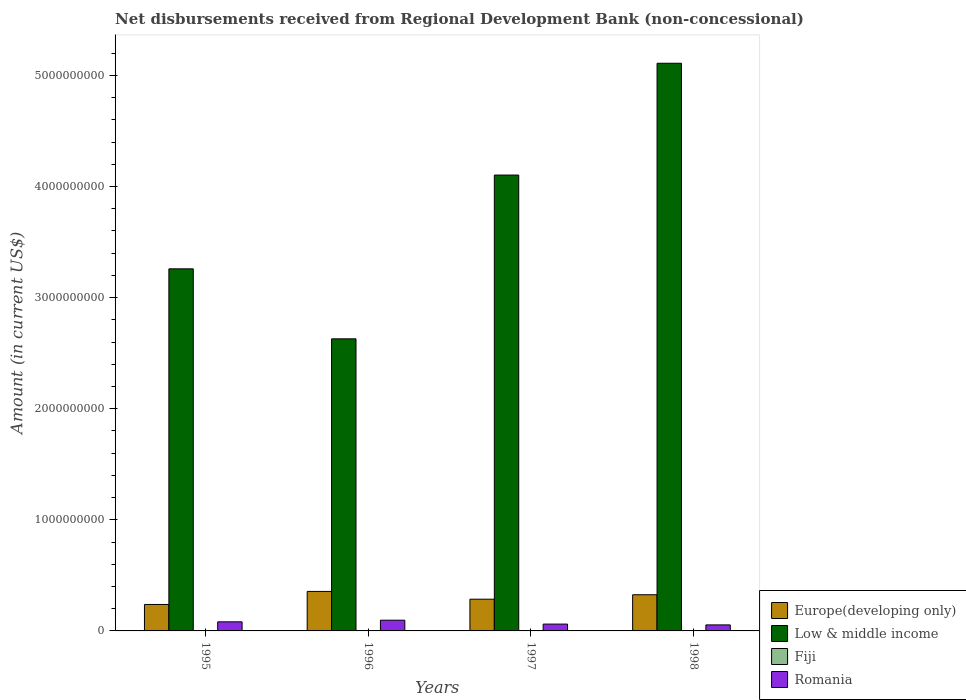How many different coloured bars are there?
Make the answer very short. 4. Are the number of bars per tick equal to the number of legend labels?
Ensure brevity in your answer.  No. Are the number of bars on each tick of the X-axis equal?
Your response must be concise. No. How many bars are there on the 4th tick from the left?
Your answer should be compact. 3. In how many cases, is the number of bars for a given year not equal to the number of legend labels?
Give a very brief answer. 3. What is the amount of disbursements received from Regional Development Bank in Fiji in 1995?
Provide a short and direct response. 8.55e+05. Across all years, what is the maximum amount of disbursements received from Regional Development Bank in Fiji?
Keep it short and to the point. 8.55e+05. Across all years, what is the minimum amount of disbursements received from Regional Development Bank in Fiji?
Your answer should be compact. 0. In which year was the amount of disbursements received from Regional Development Bank in Romania maximum?
Offer a terse response. 1996. What is the total amount of disbursements received from Regional Development Bank in Fiji in the graph?
Provide a succinct answer. 8.55e+05. What is the difference between the amount of disbursements received from Regional Development Bank in Low & middle income in 1995 and that in 1997?
Keep it short and to the point. -8.44e+08. What is the difference between the amount of disbursements received from Regional Development Bank in Fiji in 1996 and the amount of disbursements received from Regional Development Bank in Low & middle income in 1995?
Offer a very short reply. -3.26e+09. What is the average amount of disbursements received from Regional Development Bank in Low & middle income per year?
Your answer should be compact. 3.78e+09. In the year 1995, what is the difference between the amount of disbursements received from Regional Development Bank in Romania and amount of disbursements received from Regional Development Bank in Fiji?
Your answer should be very brief. 8.10e+07. What is the ratio of the amount of disbursements received from Regional Development Bank in Low & middle income in 1995 to that in 1997?
Your response must be concise. 0.79. Is the amount of disbursements received from Regional Development Bank in Romania in 1996 less than that in 1998?
Your response must be concise. No. What is the difference between the highest and the second highest amount of disbursements received from Regional Development Bank in Europe(developing only)?
Your response must be concise. 3.00e+07. What is the difference between the highest and the lowest amount of disbursements received from Regional Development Bank in Europe(developing only)?
Ensure brevity in your answer.  1.17e+08. Is the sum of the amount of disbursements received from Regional Development Bank in Low & middle income in 1997 and 1998 greater than the maximum amount of disbursements received from Regional Development Bank in Europe(developing only) across all years?
Offer a terse response. Yes. Is it the case that in every year, the sum of the amount of disbursements received from Regional Development Bank in Europe(developing only) and amount of disbursements received from Regional Development Bank in Low & middle income is greater than the sum of amount of disbursements received from Regional Development Bank in Fiji and amount of disbursements received from Regional Development Bank in Romania?
Make the answer very short. Yes. How many years are there in the graph?
Provide a succinct answer. 4. What is the difference between two consecutive major ticks on the Y-axis?
Make the answer very short. 1.00e+09. Are the values on the major ticks of Y-axis written in scientific E-notation?
Your response must be concise. No. Does the graph contain any zero values?
Keep it short and to the point. Yes. Where does the legend appear in the graph?
Make the answer very short. Bottom right. How many legend labels are there?
Offer a very short reply. 4. What is the title of the graph?
Offer a terse response. Net disbursements received from Regional Development Bank (non-concessional). Does "Brazil" appear as one of the legend labels in the graph?
Your answer should be compact. No. What is the label or title of the Y-axis?
Provide a short and direct response. Amount (in current US$). What is the Amount (in current US$) of Europe(developing only) in 1995?
Offer a terse response. 2.38e+08. What is the Amount (in current US$) in Low & middle income in 1995?
Your response must be concise. 3.26e+09. What is the Amount (in current US$) in Fiji in 1995?
Make the answer very short. 8.55e+05. What is the Amount (in current US$) of Romania in 1995?
Your answer should be compact. 8.18e+07. What is the Amount (in current US$) in Europe(developing only) in 1996?
Give a very brief answer. 3.56e+08. What is the Amount (in current US$) of Low & middle income in 1996?
Offer a very short reply. 2.63e+09. What is the Amount (in current US$) in Romania in 1996?
Provide a succinct answer. 9.66e+07. What is the Amount (in current US$) in Europe(developing only) in 1997?
Your response must be concise. 2.86e+08. What is the Amount (in current US$) of Low & middle income in 1997?
Keep it short and to the point. 4.10e+09. What is the Amount (in current US$) of Romania in 1997?
Give a very brief answer. 6.15e+07. What is the Amount (in current US$) of Europe(developing only) in 1998?
Your answer should be very brief. 3.26e+08. What is the Amount (in current US$) in Low & middle income in 1998?
Your answer should be very brief. 5.11e+09. What is the Amount (in current US$) of Fiji in 1998?
Your response must be concise. 0. What is the Amount (in current US$) in Romania in 1998?
Your answer should be very brief. 5.42e+07. Across all years, what is the maximum Amount (in current US$) of Europe(developing only)?
Make the answer very short. 3.56e+08. Across all years, what is the maximum Amount (in current US$) in Low & middle income?
Provide a succinct answer. 5.11e+09. Across all years, what is the maximum Amount (in current US$) of Fiji?
Provide a short and direct response. 8.55e+05. Across all years, what is the maximum Amount (in current US$) in Romania?
Keep it short and to the point. 9.66e+07. Across all years, what is the minimum Amount (in current US$) in Europe(developing only)?
Offer a terse response. 2.38e+08. Across all years, what is the minimum Amount (in current US$) in Low & middle income?
Provide a succinct answer. 2.63e+09. Across all years, what is the minimum Amount (in current US$) in Romania?
Your answer should be compact. 5.42e+07. What is the total Amount (in current US$) in Europe(developing only) in the graph?
Give a very brief answer. 1.21e+09. What is the total Amount (in current US$) in Low & middle income in the graph?
Keep it short and to the point. 1.51e+1. What is the total Amount (in current US$) in Fiji in the graph?
Keep it short and to the point. 8.55e+05. What is the total Amount (in current US$) in Romania in the graph?
Offer a terse response. 2.94e+08. What is the difference between the Amount (in current US$) in Europe(developing only) in 1995 and that in 1996?
Give a very brief answer. -1.17e+08. What is the difference between the Amount (in current US$) in Low & middle income in 1995 and that in 1996?
Offer a terse response. 6.30e+08. What is the difference between the Amount (in current US$) of Romania in 1995 and that in 1996?
Your response must be concise. -1.48e+07. What is the difference between the Amount (in current US$) of Europe(developing only) in 1995 and that in 1997?
Ensure brevity in your answer.  -4.73e+07. What is the difference between the Amount (in current US$) in Low & middle income in 1995 and that in 1997?
Your response must be concise. -8.44e+08. What is the difference between the Amount (in current US$) in Romania in 1995 and that in 1997?
Keep it short and to the point. 2.03e+07. What is the difference between the Amount (in current US$) in Europe(developing only) in 1995 and that in 1998?
Your response must be concise. -8.75e+07. What is the difference between the Amount (in current US$) in Low & middle income in 1995 and that in 1998?
Offer a very short reply. -1.85e+09. What is the difference between the Amount (in current US$) of Romania in 1995 and that in 1998?
Keep it short and to the point. 2.76e+07. What is the difference between the Amount (in current US$) in Europe(developing only) in 1996 and that in 1997?
Your answer should be compact. 7.01e+07. What is the difference between the Amount (in current US$) in Low & middle income in 1996 and that in 1997?
Provide a succinct answer. -1.47e+09. What is the difference between the Amount (in current US$) of Romania in 1996 and that in 1997?
Ensure brevity in your answer.  3.51e+07. What is the difference between the Amount (in current US$) of Europe(developing only) in 1996 and that in 1998?
Keep it short and to the point. 3.00e+07. What is the difference between the Amount (in current US$) in Low & middle income in 1996 and that in 1998?
Your answer should be very brief. -2.48e+09. What is the difference between the Amount (in current US$) of Romania in 1996 and that in 1998?
Offer a very short reply. 4.24e+07. What is the difference between the Amount (in current US$) in Europe(developing only) in 1997 and that in 1998?
Your answer should be compact. -4.02e+07. What is the difference between the Amount (in current US$) in Low & middle income in 1997 and that in 1998?
Offer a very short reply. -1.01e+09. What is the difference between the Amount (in current US$) of Romania in 1997 and that in 1998?
Provide a short and direct response. 7.33e+06. What is the difference between the Amount (in current US$) in Europe(developing only) in 1995 and the Amount (in current US$) in Low & middle income in 1996?
Your answer should be very brief. -2.39e+09. What is the difference between the Amount (in current US$) in Europe(developing only) in 1995 and the Amount (in current US$) in Romania in 1996?
Provide a short and direct response. 1.42e+08. What is the difference between the Amount (in current US$) of Low & middle income in 1995 and the Amount (in current US$) of Romania in 1996?
Offer a terse response. 3.16e+09. What is the difference between the Amount (in current US$) in Fiji in 1995 and the Amount (in current US$) in Romania in 1996?
Give a very brief answer. -9.58e+07. What is the difference between the Amount (in current US$) of Europe(developing only) in 1995 and the Amount (in current US$) of Low & middle income in 1997?
Give a very brief answer. -3.87e+09. What is the difference between the Amount (in current US$) in Europe(developing only) in 1995 and the Amount (in current US$) in Romania in 1997?
Provide a short and direct response. 1.77e+08. What is the difference between the Amount (in current US$) of Low & middle income in 1995 and the Amount (in current US$) of Romania in 1997?
Offer a terse response. 3.20e+09. What is the difference between the Amount (in current US$) of Fiji in 1995 and the Amount (in current US$) of Romania in 1997?
Your response must be concise. -6.07e+07. What is the difference between the Amount (in current US$) of Europe(developing only) in 1995 and the Amount (in current US$) of Low & middle income in 1998?
Give a very brief answer. -4.87e+09. What is the difference between the Amount (in current US$) in Europe(developing only) in 1995 and the Amount (in current US$) in Romania in 1998?
Give a very brief answer. 1.84e+08. What is the difference between the Amount (in current US$) of Low & middle income in 1995 and the Amount (in current US$) of Romania in 1998?
Your answer should be very brief. 3.21e+09. What is the difference between the Amount (in current US$) in Fiji in 1995 and the Amount (in current US$) in Romania in 1998?
Make the answer very short. -5.33e+07. What is the difference between the Amount (in current US$) of Europe(developing only) in 1996 and the Amount (in current US$) of Low & middle income in 1997?
Provide a succinct answer. -3.75e+09. What is the difference between the Amount (in current US$) of Europe(developing only) in 1996 and the Amount (in current US$) of Romania in 1997?
Make the answer very short. 2.94e+08. What is the difference between the Amount (in current US$) in Low & middle income in 1996 and the Amount (in current US$) in Romania in 1997?
Your answer should be compact. 2.57e+09. What is the difference between the Amount (in current US$) of Europe(developing only) in 1996 and the Amount (in current US$) of Low & middle income in 1998?
Your response must be concise. -4.75e+09. What is the difference between the Amount (in current US$) of Europe(developing only) in 1996 and the Amount (in current US$) of Romania in 1998?
Your answer should be compact. 3.01e+08. What is the difference between the Amount (in current US$) in Low & middle income in 1996 and the Amount (in current US$) in Romania in 1998?
Provide a succinct answer. 2.58e+09. What is the difference between the Amount (in current US$) of Europe(developing only) in 1997 and the Amount (in current US$) of Low & middle income in 1998?
Provide a short and direct response. -4.82e+09. What is the difference between the Amount (in current US$) in Europe(developing only) in 1997 and the Amount (in current US$) in Romania in 1998?
Your answer should be compact. 2.31e+08. What is the difference between the Amount (in current US$) of Low & middle income in 1997 and the Amount (in current US$) of Romania in 1998?
Keep it short and to the point. 4.05e+09. What is the average Amount (in current US$) in Europe(developing only) per year?
Your answer should be very brief. 3.01e+08. What is the average Amount (in current US$) of Low & middle income per year?
Make the answer very short. 3.78e+09. What is the average Amount (in current US$) in Fiji per year?
Ensure brevity in your answer.  2.14e+05. What is the average Amount (in current US$) in Romania per year?
Make the answer very short. 7.35e+07. In the year 1995, what is the difference between the Amount (in current US$) of Europe(developing only) and Amount (in current US$) of Low & middle income?
Your answer should be compact. -3.02e+09. In the year 1995, what is the difference between the Amount (in current US$) in Europe(developing only) and Amount (in current US$) in Fiji?
Keep it short and to the point. 2.37e+08. In the year 1995, what is the difference between the Amount (in current US$) of Europe(developing only) and Amount (in current US$) of Romania?
Give a very brief answer. 1.56e+08. In the year 1995, what is the difference between the Amount (in current US$) of Low & middle income and Amount (in current US$) of Fiji?
Ensure brevity in your answer.  3.26e+09. In the year 1995, what is the difference between the Amount (in current US$) of Low & middle income and Amount (in current US$) of Romania?
Your answer should be compact. 3.18e+09. In the year 1995, what is the difference between the Amount (in current US$) in Fiji and Amount (in current US$) in Romania?
Keep it short and to the point. -8.10e+07. In the year 1996, what is the difference between the Amount (in current US$) of Europe(developing only) and Amount (in current US$) of Low & middle income?
Make the answer very short. -2.27e+09. In the year 1996, what is the difference between the Amount (in current US$) of Europe(developing only) and Amount (in current US$) of Romania?
Your answer should be compact. 2.59e+08. In the year 1996, what is the difference between the Amount (in current US$) of Low & middle income and Amount (in current US$) of Romania?
Offer a terse response. 2.53e+09. In the year 1997, what is the difference between the Amount (in current US$) in Europe(developing only) and Amount (in current US$) in Low & middle income?
Offer a terse response. -3.82e+09. In the year 1997, what is the difference between the Amount (in current US$) in Europe(developing only) and Amount (in current US$) in Romania?
Offer a terse response. 2.24e+08. In the year 1997, what is the difference between the Amount (in current US$) of Low & middle income and Amount (in current US$) of Romania?
Give a very brief answer. 4.04e+09. In the year 1998, what is the difference between the Amount (in current US$) in Europe(developing only) and Amount (in current US$) in Low & middle income?
Keep it short and to the point. -4.78e+09. In the year 1998, what is the difference between the Amount (in current US$) of Europe(developing only) and Amount (in current US$) of Romania?
Offer a terse response. 2.72e+08. In the year 1998, what is the difference between the Amount (in current US$) of Low & middle income and Amount (in current US$) of Romania?
Your response must be concise. 5.06e+09. What is the ratio of the Amount (in current US$) of Europe(developing only) in 1995 to that in 1996?
Make the answer very short. 0.67. What is the ratio of the Amount (in current US$) in Low & middle income in 1995 to that in 1996?
Your answer should be very brief. 1.24. What is the ratio of the Amount (in current US$) of Romania in 1995 to that in 1996?
Your answer should be compact. 0.85. What is the ratio of the Amount (in current US$) in Europe(developing only) in 1995 to that in 1997?
Your answer should be very brief. 0.83. What is the ratio of the Amount (in current US$) in Low & middle income in 1995 to that in 1997?
Your answer should be compact. 0.79. What is the ratio of the Amount (in current US$) of Romania in 1995 to that in 1997?
Your answer should be very brief. 1.33. What is the ratio of the Amount (in current US$) in Europe(developing only) in 1995 to that in 1998?
Keep it short and to the point. 0.73. What is the ratio of the Amount (in current US$) of Low & middle income in 1995 to that in 1998?
Keep it short and to the point. 0.64. What is the ratio of the Amount (in current US$) in Romania in 1995 to that in 1998?
Your answer should be very brief. 1.51. What is the ratio of the Amount (in current US$) in Europe(developing only) in 1996 to that in 1997?
Offer a terse response. 1.25. What is the ratio of the Amount (in current US$) of Low & middle income in 1996 to that in 1997?
Offer a very short reply. 0.64. What is the ratio of the Amount (in current US$) of Romania in 1996 to that in 1997?
Keep it short and to the point. 1.57. What is the ratio of the Amount (in current US$) of Europe(developing only) in 1996 to that in 1998?
Your response must be concise. 1.09. What is the ratio of the Amount (in current US$) in Low & middle income in 1996 to that in 1998?
Provide a short and direct response. 0.51. What is the ratio of the Amount (in current US$) of Romania in 1996 to that in 1998?
Offer a terse response. 1.78. What is the ratio of the Amount (in current US$) of Europe(developing only) in 1997 to that in 1998?
Give a very brief answer. 0.88. What is the ratio of the Amount (in current US$) of Low & middle income in 1997 to that in 1998?
Make the answer very short. 0.8. What is the ratio of the Amount (in current US$) in Romania in 1997 to that in 1998?
Keep it short and to the point. 1.14. What is the difference between the highest and the second highest Amount (in current US$) of Europe(developing only)?
Ensure brevity in your answer.  3.00e+07. What is the difference between the highest and the second highest Amount (in current US$) in Low & middle income?
Give a very brief answer. 1.01e+09. What is the difference between the highest and the second highest Amount (in current US$) in Romania?
Provide a short and direct response. 1.48e+07. What is the difference between the highest and the lowest Amount (in current US$) in Europe(developing only)?
Provide a short and direct response. 1.17e+08. What is the difference between the highest and the lowest Amount (in current US$) in Low & middle income?
Offer a terse response. 2.48e+09. What is the difference between the highest and the lowest Amount (in current US$) of Fiji?
Ensure brevity in your answer.  8.55e+05. What is the difference between the highest and the lowest Amount (in current US$) in Romania?
Give a very brief answer. 4.24e+07. 